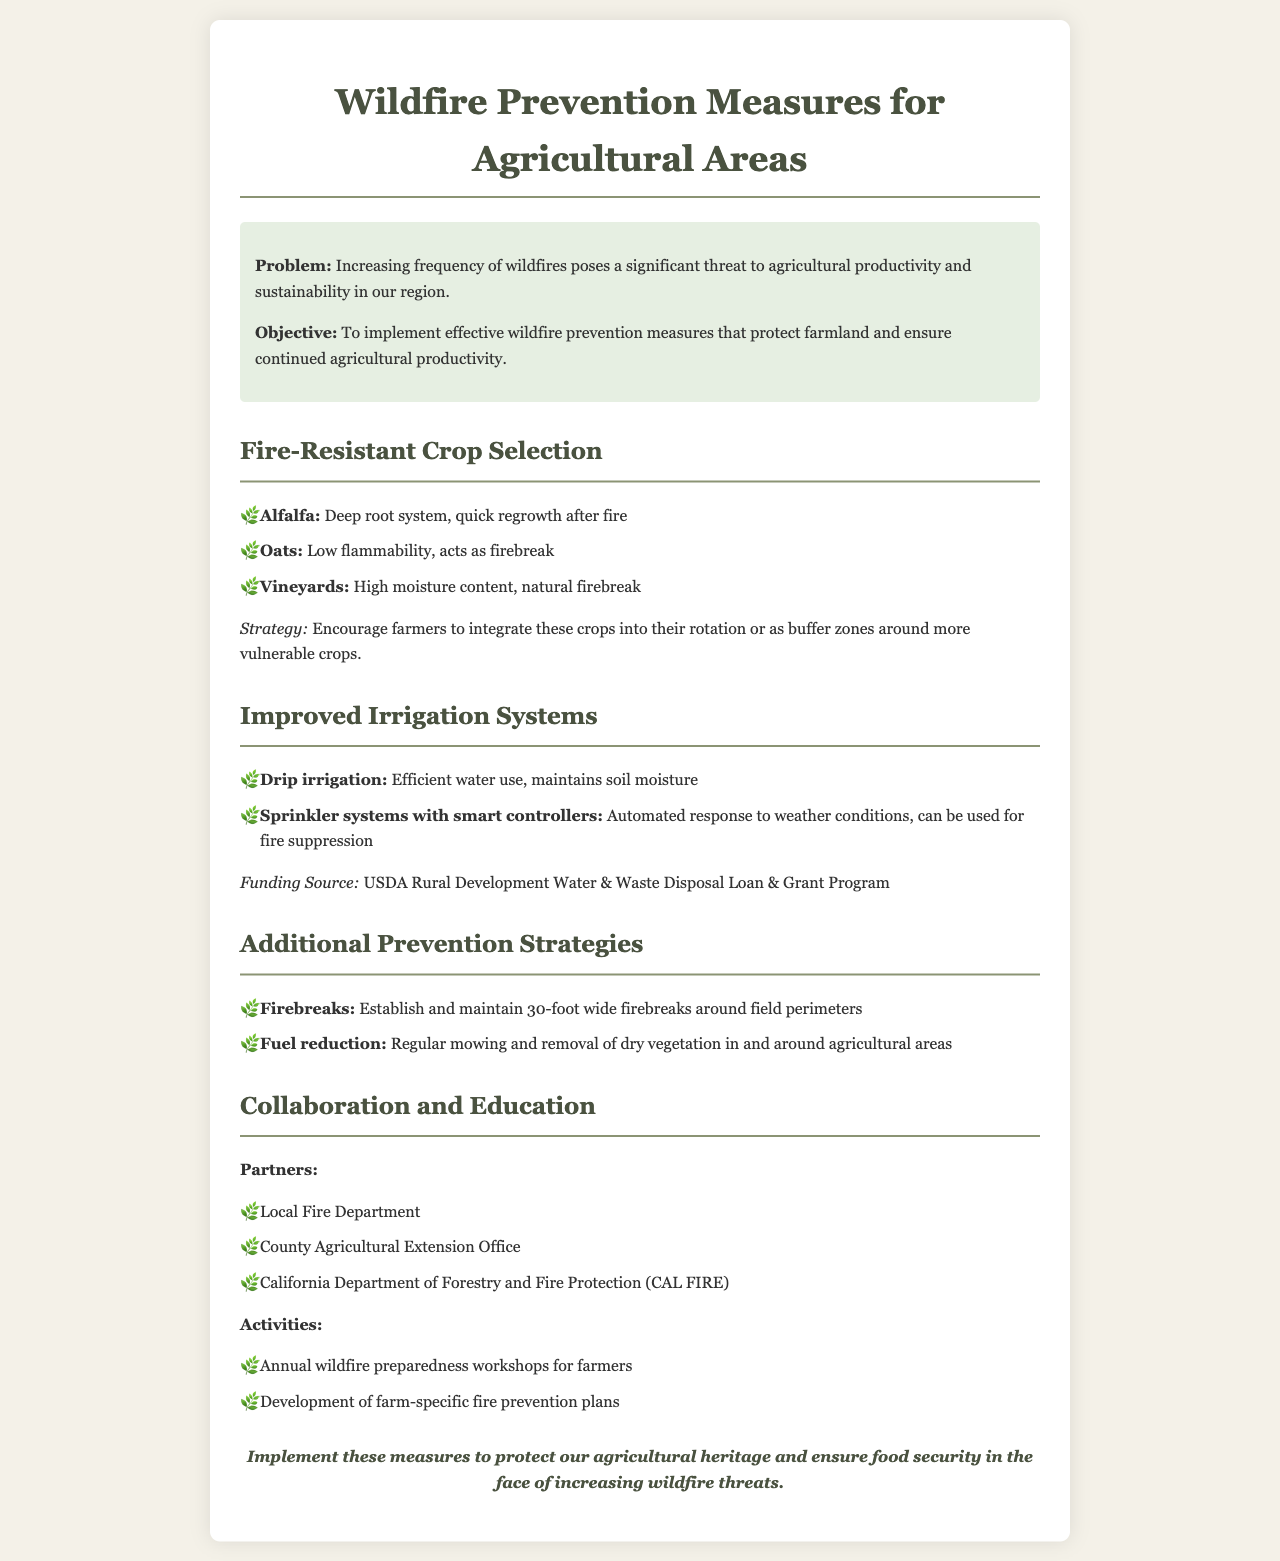What is the main problem addressed in the document? The document highlights the increasing frequency of wildfires as a significant threat to agricultural productivity and sustainability.
Answer: Increasing frequency of wildfires What crop is mentioned as having a deep root system? Alfalfa is identified in the document for having a deep root system and quick regrowth after fire.
Answer: Alfalfa What irrigation system is described as efficient in maintaining soil moisture? The document states that drip irrigation is efficient in water use and helps maintain soil moisture.
Answer: Drip irrigation What is the recommended width for establishing firebreaks? The document specifies that firebreaks should be maintained at 30 feet wide around field perimeters.
Answer: 30 feet Which organization provides funding for improved irrigation systems? The USDA Rural Development Water & Waste Disposal Loan & Grant Program is mentioned as the funding source.
Answer: USDA Rural Development What type of crop has low flammability according to the document? Oats are recognized in the document as having low flammability.
Answer: Oats What is one proposed prevention activity for farmers? The document suggests annual wildfire preparedness workshops for farmers as a preventive activity.
Answer: Annual wildfire preparedness workshops Who are the partners mentioned for collaboration in wildfire prevention? The local fire department, county agricultural extension office, and CAL FIRE are listed as partners.
Answer: Local Fire Department, County Agricultural Extension Office, CAL FIRE What is the objective of the proposed measures? The document states that the objective is to implement effective wildfire prevention measures to protect farmland.
Answer: Protect farmland 